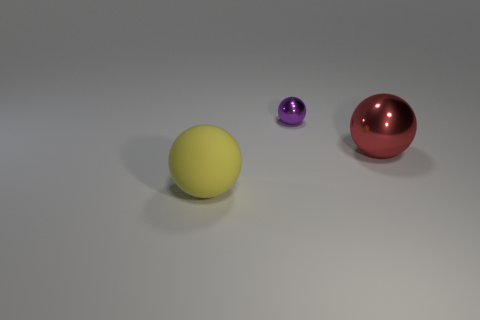There is a yellow rubber object; how many small spheres are left of it?
Keep it short and to the point. 0. Is the material of the large yellow ball the same as the tiny purple object?
Give a very brief answer. No. How many balls are both in front of the tiny thing and right of the yellow rubber ball?
Your answer should be compact. 1. How many other things are the same color as the tiny object?
Provide a succinct answer. 0. How many yellow things are either large rubber spheres or large metallic things?
Your answer should be very brief. 1. The yellow object has what size?
Keep it short and to the point. Large. What number of rubber things are either big red balls or big balls?
Your answer should be very brief. 1. Are there fewer large purple rubber objects than balls?
Offer a very short reply. Yes. How many other objects are the same material as the tiny purple thing?
Offer a very short reply. 1. There is another matte thing that is the same shape as the red thing; what size is it?
Provide a succinct answer. Large. 